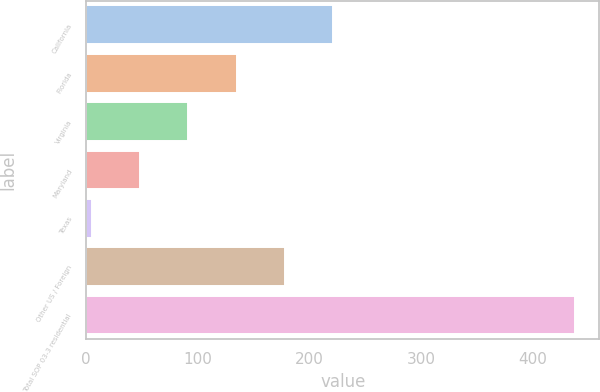<chart> <loc_0><loc_0><loc_500><loc_500><bar_chart><fcel>California<fcel>Florida<fcel>Virginia<fcel>Maryland<fcel>Texas<fcel>Other US / Foreign<fcel>Total SOP 03-3 residential<nl><fcel>221.5<fcel>134.9<fcel>91.6<fcel>48.3<fcel>5<fcel>178.2<fcel>438<nl></chart> 